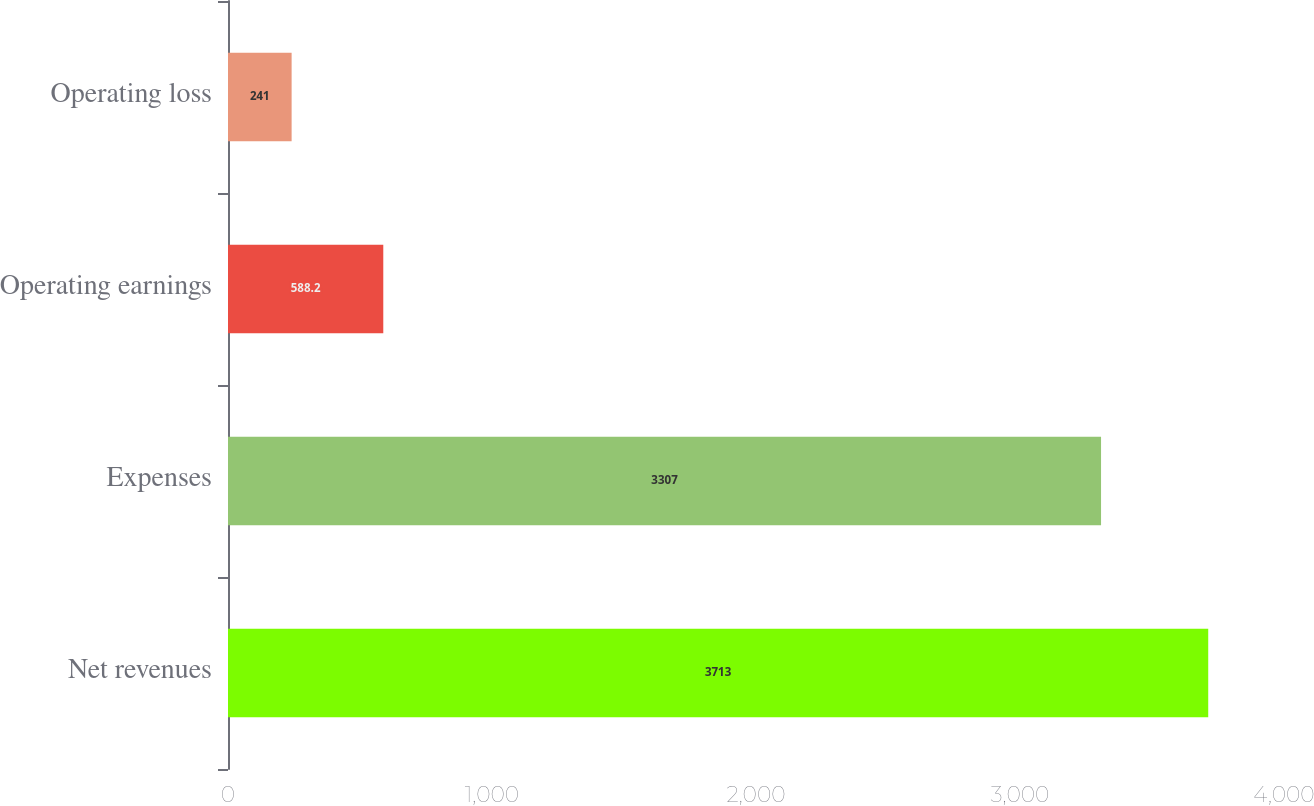<chart> <loc_0><loc_0><loc_500><loc_500><bar_chart><fcel>Net revenues<fcel>Expenses<fcel>Operating earnings<fcel>Operating loss<nl><fcel>3713<fcel>3307<fcel>588.2<fcel>241<nl></chart> 